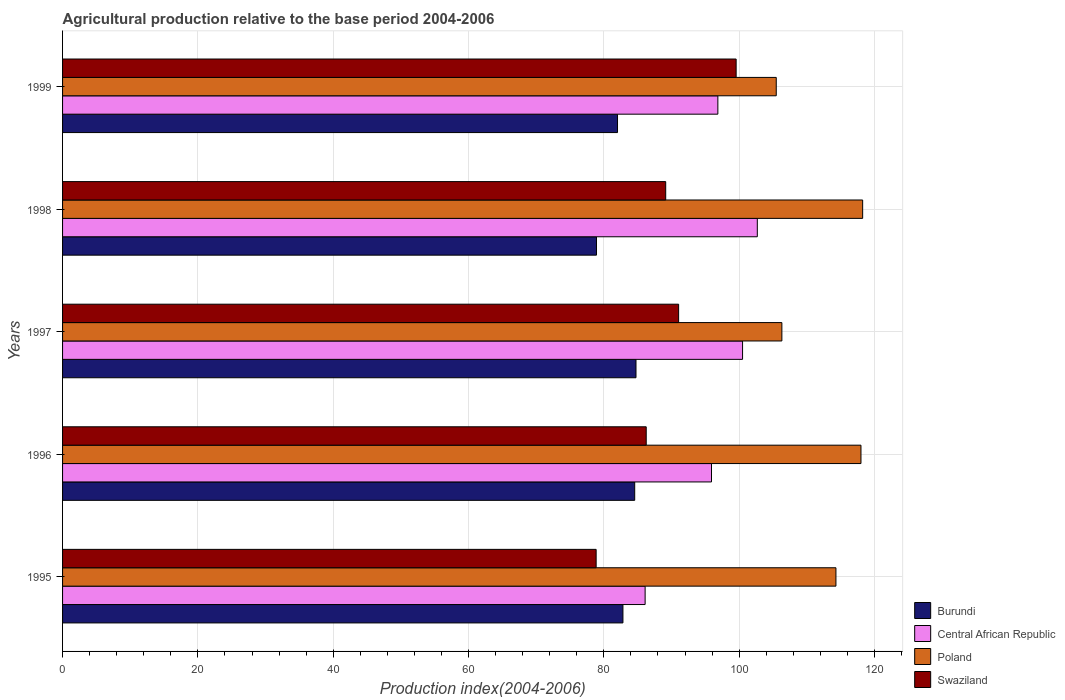How many different coloured bars are there?
Offer a terse response. 4. Are the number of bars per tick equal to the number of legend labels?
Keep it short and to the point. Yes. Are the number of bars on each tick of the Y-axis equal?
Provide a succinct answer. Yes. How many bars are there on the 5th tick from the top?
Make the answer very short. 4. What is the label of the 1st group of bars from the top?
Your response must be concise. 1999. In how many cases, is the number of bars for a given year not equal to the number of legend labels?
Your response must be concise. 0. What is the agricultural production index in Burundi in 1999?
Provide a succinct answer. 82.02. Across all years, what is the maximum agricultural production index in Burundi?
Keep it short and to the point. 84.75. Across all years, what is the minimum agricultural production index in Swaziland?
Provide a short and direct response. 78.86. In which year was the agricultural production index in Central African Republic minimum?
Keep it short and to the point. 1995. What is the total agricultural production index in Central African Republic in the graph?
Your response must be concise. 482.04. What is the difference between the agricultural production index in Swaziland in 1995 and that in 1997?
Your answer should be very brief. -12.19. What is the difference between the agricultural production index in Poland in 1996 and the agricultural production index in Swaziland in 1995?
Offer a terse response. 39.14. What is the average agricultural production index in Swaziland per year?
Keep it short and to the point. 88.97. In the year 1997, what is the difference between the agricultural production index in Burundi and agricultural production index in Poland?
Your response must be concise. -21.56. What is the ratio of the agricultural production index in Central African Republic in 1996 to that in 1999?
Keep it short and to the point. 0.99. Is the difference between the agricultural production index in Burundi in 1995 and 1997 greater than the difference between the agricultural production index in Poland in 1995 and 1997?
Offer a very short reply. No. What is the difference between the highest and the lowest agricultural production index in Poland?
Your response must be concise. 12.77. In how many years, is the agricultural production index in Swaziland greater than the average agricultural production index in Swaziland taken over all years?
Your answer should be compact. 3. What does the 2nd bar from the top in 1996 represents?
Make the answer very short. Poland. Is it the case that in every year, the sum of the agricultural production index in Central African Republic and agricultural production index in Swaziland is greater than the agricultural production index in Poland?
Your answer should be very brief. Yes. How many bars are there?
Offer a terse response. 20. Are all the bars in the graph horizontal?
Offer a terse response. Yes. Does the graph contain grids?
Provide a short and direct response. Yes. Where does the legend appear in the graph?
Offer a very short reply. Bottom right. What is the title of the graph?
Provide a short and direct response. Agricultural production relative to the base period 2004-2006. What is the label or title of the X-axis?
Keep it short and to the point. Production index(2004-2006). What is the Production index(2004-2006) in Burundi in 1995?
Your response must be concise. 82.82. What is the Production index(2004-2006) of Central African Republic in 1995?
Give a very brief answer. 86.1. What is the Production index(2004-2006) of Poland in 1995?
Provide a succinct answer. 114.3. What is the Production index(2004-2006) in Swaziland in 1995?
Give a very brief answer. 78.86. What is the Production index(2004-2006) in Burundi in 1996?
Your answer should be compact. 84.56. What is the Production index(2004-2006) in Central African Republic in 1996?
Your response must be concise. 95.91. What is the Production index(2004-2006) of Poland in 1996?
Keep it short and to the point. 118. What is the Production index(2004-2006) in Swaziland in 1996?
Keep it short and to the point. 86.26. What is the Production index(2004-2006) of Burundi in 1997?
Provide a succinct answer. 84.75. What is the Production index(2004-2006) in Central African Republic in 1997?
Offer a very short reply. 100.5. What is the Production index(2004-2006) in Poland in 1997?
Keep it short and to the point. 106.31. What is the Production index(2004-2006) of Swaziland in 1997?
Your answer should be compact. 91.05. What is the Production index(2004-2006) of Burundi in 1998?
Offer a very short reply. 78.91. What is the Production index(2004-2006) in Central African Republic in 1998?
Provide a succinct answer. 102.68. What is the Production index(2004-2006) in Poland in 1998?
Give a very brief answer. 118.25. What is the Production index(2004-2006) of Swaziland in 1998?
Keep it short and to the point. 89.14. What is the Production index(2004-2006) of Burundi in 1999?
Offer a terse response. 82.02. What is the Production index(2004-2006) in Central African Republic in 1999?
Provide a succinct answer. 96.85. What is the Production index(2004-2006) in Poland in 1999?
Provide a short and direct response. 105.48. What is the Production index(2004-2006) in Swaziland in 1999?
Offer a terse response. 99.55. Across all years, what is the maximum Production index(2004-2006) in Burundi?
Provide a short and direct response. 84.75. Across all years, what is the maximum Production index(2004-2006) of Central African Republic?
Keep it short and to the point. 102.68. Across all years, what is the maximum Production index(2004-2006) in Poland?
Your response must be concise. 118.25. Across all years, what is the maximum Production index(2004-2006) of Swaziland?
Offer a very short reply. 99.55. Across all years, what is the minimum Production index(2004-2006) in Burundi?
Provide a short and direct response. 78.91. Across all years, what is the minimum Production index(2004-2006) of Central African Republic?
Make the answer very short. 86.1. Across all years, what is the minimum Production index(2004-2006) in Poland?
Give a very brief answer. 105.48. Across all years, what is the minimum Production index(2004-2006) of Swaziland?
Make the answer very short. 78.86. What is the total Production index(2004-2006) in Burundi in the graph?
Your response must be concise. 413.06. What is the total Production index(2004-2006) in Central African Republic in the graph?
Provide a succinct answer. 482.04. What is the total Production index(2004-2006) of Poland in the graph?
Your answer should be very brief. 562.34. What is the total Production index(2004-2006) of Swaziland in the graph?
Make the answer very short. 444.86. What is the difference between the Production index(2004-2006) of Burundi in 1995 and that in 1996?
Make the answer very short. -1.74. What is the difference between the Production index(2004-2006) of Central African Republic in 1995 and that in 1996?
Make the answer very short. -9.81. What is the difference between the Production index(2004-2006) in Burundi in 1995 and that in 1997?
Provide a short and direct response. -1.93. What is the difference between the Production index(2004-2006) of Central African Republic in 1995 and that in 1997?
Your answer should be compact. -14.4. What is the difference between the Production index(2004-2006) of Poland in 1995 and that in 1997?
Your answer should be compact. 7.99. What is the difference between the Production index(2004-2006) in Swaziland in 1995 and that in 1997?
Ensure brevity in your answer.  -12.19. What is the difference between the Production index(2004-2006) in Burundi in 1995 and that in 1998?
Your answer should be very brief. 3.91. What is the difference between the Production index(2004-2006) in Central African Republic in 1995 and that in 1998?
Offer a terse response. -16.58. What is the difference between the Production index(2004-2006) of Poland in 1995 and that in 1998?
Ensure brevity in your answer.  -3.95. What is the difference between the Production index(2004-2006) of Swaziland in 1995 and that in 1998?
Offer a terse response. -10.28. What is the difference between the Production index(2004-2006) in Burundi in 1995 and that in 1999?
Your answer should be very brief. 0.8. What is the difference between the Production index(2004-2006) of Central African Republic in 1995 and that in 1999?
Your response must be concise. -10.75. What is the difference between the Production index(2004-2006) of Poland in 1995 and that in 1999?
Make the answer very short. 8.82. What is the difference between the Production index(2004-2006) in Swaziland in 1995 and that in 1999?
Offer a terse response. -20.69. What is the difference between the Production index(2004-2006) of Burundi in 1996 and that in 1997?
Ensure brevity in your answer.  -0.19. What is the difference between the Production index(2004-2006) of Central African Republic in 1996 and that in 1997?
Your response must be concise. -4.59. What is the difference between the Production index(2004-2006) of Poland in 1996 and that in 1997?
Offer a very short reply. 11.69. What is the difference between the Production index(2004-2006) in Swaziland in 1996 and that in 1997?
Your answer should be very brief. -4.79. What is the difference between the Production index(2004-2006) of Burundi in 1996 and that in 1998?
Offer a very short reply. 5.65. What is the difference between the Production index(2004-2006) in Central African Republic in 1996 and that in 1998?
Offer a very short reply. -6.77. What is the difference between the Production index(2004-2006) of Poland in 1996 and that in 1998?
Your response must be concise. -0.25. What is the difference between the Production index(2004-2006) in Swaziland in 1996 and that in 1998?
Give a very brief answer. -2.88. What is the difference between the Production index(2004-2006) of Burundi in 1996 and that in 1999?
Your response must be concise. 2.54. What is the difference between the Production index(2004-2006) in Central African Republic in 1996 and that in 1999?
Keep it short and to the point. -0.94. What is the difference between the Production index(2004-2006) in Poland in 1996 and that in 1999?
Keep it short and to the point. 12.52. What is the difference between the Production index(2004-2006) of Swaziland in 1996 and that in 1999?
Make the answer very short. -13.29. What is the difference between the Production index(2004-2006) of Burundi in 1997 and that in 1998?
Your response must be concise. 5.84. What is the difference between the Production index(2004-2006) in Central African Republic in 1997 and that in 1998?
Provide a succinct answer. -2.18. What is the difference between the Production index(2004-2006) in Poland in 1997 and that in 1998?
Make the answer very short. -11.94. What is the difference between the Production index(2004-2006) of Swaziland in 1997 and that in 1998?
Your answer should be compact. 1.91. What is the difference between the Production index(2004-2006) of Burundi in 1997 and that in 1999?
Offer a terse response. 2.73. What is the difference between the Production index(2004-2006) of Central African Republic in 1997 and that in 1999?
Your answer should be very brief. 3.65. What is the difference between the Production index(2004-2006) in Poland in 1997 and that in 1999?
Keep it short and to the point. 0.83. What is the difference between the Production index(2004-2006) of Swaziland in 1997 and that in 1999?
Provide a succinct answer. -8.5. What is the difference between the Production index(2004-2006) of Burundi in 1998 and that in 1999?
Offer a very short reply. -3.11. What is the difference between the Production index(2004-2006) in Central African Republic in 1998 and that in 1999?
Offer a very short reply. 5.83. What is the difference between the Production index(2004-2006) in Poland in 1998 and that in 1999?
Ensure brevity in your answer.  12.77. What is the difference between the Production index(2004-2006) in Swaziland in 1998 and that in 1999?
Offer a terse response. -10.41. What is the difference between the Production index(2004-2006) in Burundi in 1995 and the Production index(2004-2006) in Central African Republic in 1996?
Offer a very short reply. -13.09. What is the difference between the Production index(2004-2006) of Burundi in 1995 and the Production index(2004-2006) of Poland in 1996?
Your answer should be very brief. -35.18. What is the difference between the Production index(2004-2006) in Burundi in 1995 and the Production index(2004-2006) in Swaziland in 1996?
Make the answer very short. -3.44. What is the difference between the Production index(2004-2006) of Central African Republic in 1995 and the Production index(2004-2006) of Poland in 1996?
Provide a short and direct response. -31.9. What is the difference between the Production index(2004-2006) in Central African Republic in 1995 and the Production index(2004-2006) in Swaziland in 1996?
Offer a terse response. -0.16. What is the difference between the Production index(2004-2006) of Poland in 1995 and the Production index(2004-2006) of Swaziland in 1996?
Offer a very short reply. 28.04. What is the difference between the Production index(2004-2006) of Burundi in 1995 and the Production index(2004-2006) of Central African Republic in 1997?
Provide a short and direct response. -17.68. What is the difference between the Production index(2004-2006) in Burundi in 1995 and the Production index(2004-2006) in Poland in 1997?
Provide a short and direct response. -23.49. What is the difference between the Production index(2004-2006) in Burundi in 1995 and the Production index(2004-2006) in Swaziland in 1997?
Give a very brief answer. -8.23. What is the difference between the Production index(2004-2006) in Central African Republic in 1995 and the Production index(2004-2006) in Poland in 1997?
Your answer should be very brief. -20.21. What is the difference between the Production index(2004-2006) of Central African Republic in 1995 and the Production index(2004-2006) of Swaziland in 1997?
Provide a succinct answer. -4.95. What is the difference between the Production index(2004-2006) in Poland in 1995 and the Production index(2004-2006) in Swaziland in 1997?
Your answer should be compact. 23.25. What is the difference between the Production index(2004-2006) in Burundi in 1995 and the Production index(2004-2006) in Central African Republic in 1998?
Your response must be concise. -19.86. What is the difference between the Production index(2004-2006) in Burundi in 1995 and the Production index(2004-2006) in Poland in 1998?
Your answer should be compact. -35.43. What is the difference between the Production index(2004-2006) in Burundi in 1995 and the Production index(2004-2006) in Swaziland in 1998?
Provide a short and direct response. -6.32. What is the difference between the Production index(2004-2006) of Central African Republic in 1995 and the Production index(2004-2006) of Poland in 1998?
Your answer should be very brief. -32.15. What is the difference between the Production index(2004-2006) of Central African Republic in 1995 and the Production index(2004-2006) of Swaziland in 1998?
Your response must be concise. -3.04. What is the difference between the Production index(2004-2006) of Poland in 1995 and the Production index(2004-2006) of Swaziland in 1998?
Keep it short and to the point. 25.16. What is the difference between the Production index(2004-2006) in Burundi in 1995 and the Production index(2004-2006) in Central African Republic in 1999?
Provide a short and direct response. -14.03. What is the difference between the Production index(2004-2006) in Burundi in 1995 and the Production index(2004-2006) in Poland in 1999?
Your response must be concise. -22.66. What is the difference between the Production index(2004-2006) of Burundi in 1995 and the Production index(2004-2006) of Swaziland in 1999?
Make the answer very short. -16.73. What is the difference between the Production index(2004-2006) of Central African Republic in 1995 and the Production index(2004-2006) of Poland in 1999?
Your response must be concise. -19.38. What is the difference between the Production index(2004-2006) in Central African Republic in 1995 and the Production index(2004-2006) in Swaziland in 1999?
Offer a terse response. -13.45. What is the difference between the Production index(2004-2006) of Poland in 1995 and the Production index(2004-2006) of Swaziland in 1999?
Give a very brief answer. 14.75. What is the difference between the Production index(2004-2006) of Burundi in 1996 and the Production index(2004-2006) of Central African Republic in 1997?
Your response must be concise. -15.94. What is the difference between the Production index(2004-2006) in Burundi in 1996 and the Production index(2004-2006) in Poland in 1997?
Provide a short and direct response. -21.75. What is the difference between the Production index(2004-2006) of Burundi in 1996 and the Production index(2004-2006) of Swaziland in 1997?
Ensure brevity in your answer.  -6.49. What is the difference between the Production index(2004-2006) in Central African Republic in 1996 and the Production index(2004-2006) in Poland in 1997?
Give a very brief answer. -10.4. What is the difference between the Production index(2004-2006) of Central African Republic in 1996 and the Production index(2004-2006) of Swaziland in 1997?
Your response must be concise. 4.86. What is the difference between the Production index(2004-2006) of Poland in 1996 and the Production index(2004-2006) of Swaziland in 1997?
Give a very brief answer. 26.95. What is the difference between the Production index(2004-2006) of Burundi in 1996 and the Production index(2004-2006) of Central African Republic in 1998?
Provide a short and direct response. -18.12. What is the difference between the Production index(2004-2006) in Burundi in 1996 and the Production index(2004-2006) in Poland in 1998?
Keep it short and to the point. -33.69. What is the difference between the Production index(2004-2006) in Burundi in 1996 and the Production index(2004-2006) in Swaziland in 1998?
Offer a terse response. -4.58. What is the difference between the Production index(2004-2006) in Central African Republic in 1996 and the Production index(2004-2006) in Poland in 1998?
Your answer should be compact. -22.34. What is the difference between the Production index(2004-2006) of Central African Republic in 1996 and the Production index(2004-2006) of Swaziland in 1998?
Offer a very short reply. 6.77. What is the difference between the Production index(2004-2006) in Poland in 1996 and the Production index(2004-2006) in Swaziland in 1998?
Make the answer very short. 28.86. What is the difference between the Production index(2004-2006) of Burundi in 1996 and the Production index(2004-2006) of Central African Republic in 1999?
Your answer should be compact. -12.29. What is the difference between the Production index(2004-2006) of Burundi in 1996 and the Production index(2004-2006) of Poland in 1999?
Offer a terse response. -20.92. What is the difference between the Production index(2004-2006) in Burundi in 1996 and the Production index(2004-2006) in Swaziland in 1999?
Give a very brief answer. -14.99. What is the difference between the Production index(2004-2006) of Central African Republic in 1996 and the Production index(2004-2006) of Poland in 1999?
Keep it short and to the point. -9.57. What is the difference between the Production index(2004-2006) in Central African Republic in 1996 and the Production index(2004-2006) in Swaziland in 1999?
Your answer should be very brief. -3.64. What is the difference between the Production index(2004-2006) of Poland in 1996 and the Production index(2004-2006) of Swaziland in 1999?
Ensure brevity in your answer.  18.45. What is the difference between the Production index(2004-2006) of Burundi in 1997 and the Production index(2004-2006) of Central African Republic in 1998?
Provide a succinct answer. -17.93. What is the difference between the Production index(2004-2006) in Burundi in 1997 and the Production index(2004-2006) in Poland in 1998?
Offer a terse response. -33.5. What is the difference between the Production index(2004-2006) in Burundi in 1997 and the Production index(2004-2006) in Swaziland in 1998?
Ensure brevity in your answer.  -4.39. What is the difference between the Production index(2004-2006) in Central African Republic in 1997 and the Production index(2004-2006) in Poland in 1998?
Keep it short and to the point. -17.75. What is the difference between the Production index(2004-2006) in Central African Republic in 1997 and the Production index(2004-2006) in Swaziland in 1998?
Your answer should be compact. 11.36. What is the difference between the Production index(2004-2006) in Poland in 1997 and the Production index(2004-2006) in Swaziland in 1998?
Your response must be concise. 17.17. What is the difference between the Production index(2004-2006) in Burundi in 1997 and the Production index(2004-2006) in Central African Republic in 1999?
Ensure brevity in your answer.  -12.1. What is the difference between the Production index(2004-2006) in Burundi in 1997 and the Production index(2004-2006) in Poland in 1999?
Your answer should be very brief. -20.73. What is the difference between the Production index(2004-2006) in Burundi in 1997 and the Production index(2004-2006) in Swaziland in 1999?
Offer a terse response. -14.8. What is the difference between the Production index(2004-2006) in Central African Republic in 1997 and the Production index(2004-2006) in Poland in 1999?
Give a very brief answer. -4.98. What is the difference between the Production index(2004-2006) of Poland in 1997 and the Production index(2004-2006) of Swaziland in 1999?
Your answer should be compact. 6.76. What is the difference between the Production index(2004-2006) of Burundi in 1998 and the Production index(2004-2006) of Central African Republic in 1999?
Your answer should be compact. -17.94. What is the difference between the Production index(2004-2006) of Burundi in 1998 and the Production index(2004-2006) of Poland in 1999?
Offer a terse response. -26.57. What is the difference between the Production index(2004-2006) of Burundi in 1998 and the Production index(2004-2006) of Swaziland in 1999?
Keep it short and to the point. -20.64. What is the difference between the Production index(2004-2006) in Central African Republic in 1998 and the Production index(2004-2006) in Swaziland in 1999?
Offer a very short reply. 3.13. What is the average Production index(2004-2006) in Burundi per year?
Your answer should be very brief. 82.61. What is the average Production index(2004-2006) in Central African Republic per year?
Give a very brief answer. 96.41. What is the average Production index(2004-2006) in Poland per year?
Provide a short and direct response. 112.47. What is the average Production index(2004-2006) of Swaziland per year?
Your answer should be compact. 88.97. In the year 1995, what is the difference between the Production index(2004-2006) of Burundi and Production index(2004-2006) of Central African Republic?
Provide a short and direct response. -3.28. In the year 1995, what is the difference between the Production index(2004-2006) in Burundi and Production index(2004-2006) in Poland?
Provide a short and direct response. -31.48. In the year 1995, what is the difference between the Production index(2004-2006) in Burundi and Production index(2004-2006) in Swaziland?
Make the answer very short. 3.96. In the year 1995, what is the difference between the Production index(2004-2006) of Central African Republic and Production index(2004-2006) of Poland?
Offer a terse response. -28.2. In the year 1995, what is the difference between the Production index(2004-2006) in Central African Republic and Production index(2004-2006) in Swaziland?
Provide a short and direct response. 7.24. In the year 1995, what is the difference between the Production index(2004-2006) of Poland and Production index(2004-2006) of Swaziland?
Your answer should be compact. 35.44. In the year 1996, what is the difference between the Production index(2004-2006) of Burundi and Production index(2004-2006) of Central African Republic?
Provide a short and direct response. -11.35. In the year 1996, what is the difference between the Production index(2004-2006) in Burundi and Production index(2004-2006) in Poland?
Provide a short and direct response. -33.44. In the year 1996, what is the difference between the Production index(2004-2006) of Central African Republic and Production index(2004-2006) of Poland?
Your answer should be very brief. -22.09. In the year 1996, what is the difference between the Production index(2004-2006) of Central African Republic and Production index(2004-2006) of Swaziland?
Your answer should be very brief. 9.65. In the year 1996, what is the difference between the Production index(2004-2006) in Poland and Production index(2004-2006) in Swaziland?
Make the answer very short. 31.74. In the year 1997, what is the difference between the Production index(2004-2006) in Burundi and Production index(2004-2006) in Central African Republic?
Your response must be concise. -15.75. In the year 1997, what is the difference between the Production index(2004-2006) in Burundi and Production index(2004-2006) in Poland?
Your response must be concise. -21.56. In the year 1997, what is the difference between the Production index(2004-2006) in Central African Republic and Production index(2004-2006) in Poland?
Make the answer very short. -5.81. In the year 1997, what is the difference between the Production index(2004-2006) in Central African Republic and Production index(2004-2006) in Swaziland?
Give a very brief answer. 9.45. In the year 1997, what is the difference between the Production index(2004-2006) in Poland and Production index(2004-2006) in Swaziland?
Your response must be concise. 15.26. In the year 1998, what is the difference between the Production index(2004-2006) of Burundi and Production index(2004-2006) of Central African Republic?
Your answer should be compact. -23.77. In the year 1998, what is the difference between the Production index(2004-2006) in Burundi and Production index(2004-2006) in Poland?
Keep it short and to the point. -39.34. In the year 1998, what is the difference between the Production index(2004-2006) of Burundi and Production index(2004-2006) of Swaziland?
Make the answer very short. -10.23. In the year 1998, what is the difference between the Production index(2004-2006) in Central African Republic and Production index(2004-2006) in Poland?
Provide a succinct answer. -15.57. In the year 1998, what is the difference between the Production index(2004-2006) of Central African Republic and Production index(2004-2006) of Swaziland?
Your answer should be compact. 13.54. In the year 1998, what is the difference between the Production index(2004-2006) of Poland and Production index(2004-2006) of Swaziland?
Offer a terse response. 29.11. In the year 1999, what is the difference between the Production index(2004-2006) of Burundi and Production index(2004-2006) of Central African Republic?
Offer a very short reply. -14.83. In the year 1999, what is the difference between the Production index(2004-2006) of Burundi and Production index(2004-2006) of Poland?
Offer a very short reply. -23.46. In the year 1999, what is the difference between the Production index(2004-2006) of Burundi and Production index(2004-2006) of Swaziland?
Provide a short and direct response. -17.53. In the year 1999, what is the difference between the Production index(2004-2006) of Central African Republic and Production index(2004-2006) of Poland?
Your answer should be very brief. -8.63. In the year 1999, what is the difference between the Production index(2004-2006) in Poland and Production index(2004-2006) in Swaziland?
Keep it short and to the point. 5.93. What is the ratio of the Production index(2004-2006) in Burundi in 1995 to that in 1996?
Your response must be concise. 0.98. What is the ratio of the Production index(2004-2006) of Central African Republic in 1995 to that in 1996?
Provide a short and direct response. 0.9. What is the ratio of the Production index(2004-2006) in Poland in 1995 to that in 1996?
Ensure brevity in your answer.  0.97. What is the ratio of the Production index(2004-2006) in Swaziland in 1995 to that in 1996?
Offer a very short reply. 0.91. What is the ratio of the Production index(2004-2006) in Burundi in 1995 to that in 1997?
Give a very brief answer. 0.98. What is the ratio of the Production index(2004-2006) of Central African Republic in 1995 to that in 1997?
Give a very brief answer. 0.86. What is the ratio of the Production index(2004-2006) of Poland in 1995 to that in 1997?
Provide a short and direct response. 1.08. What is the ratio of the Production index(2004-2006) in Swaziland in 1995 to that in 1997?
Provide a short and direct response. 0.87. What is the ratio of the Production index(2004-2006) of Burundi in 1995 to that in 1998?
Offer a very short reply. 1.05. What is the ratio of the Production index(2004-2006) in Central African Republic in 1995 to that in 1998?
Provide a short and direct response. 0.84. What is the ratio of the Production index(2004-2006) in Poland in 1995 to that in 1998?
Offer a terse response. 0.97. What is the ratio of the Production index(2004-2006) in Swaziland in 1995 to that in 1998?
Give a very brief answer. 0.88. What is the ratio of the Production index(2004-2006) of Burundi in 1995 to that in 1999?
Offer a terse response. 1.01. What is the ratio of the Production index(2004-2006) of Central African Republic in 1995 to that in 1999?
Your answer should be very brief. 0.89. What is the ratio of the Production index(2004-2006) in Poland in 1995 to that in 1999?
Keep it short and to the point. 1.08. What is the ratio of the Production index(2004-2006) of Swaziland in 1995 to that in 1999?
Offer a very short reply. 0.79. What is the ratio of the Production index(2004-2006) of Burundi in 1996 to that in 1997?
Provide a short and direct response. 1. What is the ratio of the Production index(2004-2006) of Central African Republic in 1996 to that in 1997?
Your answer should be compact. 0.95. What is the ratio of the Production index(2004-2006) in Poland in 1996 to that in 1997?
Offer a very short reply. 1.11. What is the ratio of the Production index(2004-2006) in Burundi in 1996 to that in 1998?
Provide a succinct answer. 1.07. What is the ratio of the Production index(2004-2006) of Central African Republic in 1996 to that in 1998?
Offer a very short reply. 0.93. What is the ratio of the Production index(2004-2006) in Burundi in 1996 to that in 1999?
Your answer should be very brief. 1.03. What is the ratio of the Production index(2004-2006) in Central African Republic in 1996 to that in 1999?
Provide a succinct answer. 0.99. What is the ratio of the Production index(2004-2006) of Poland in 1996 to that in 1999?
Keep it short and to the point. 1.12. What is the ratio of the Production index(2004-2006) of Swaziland in 1996 to that in 1999?
Your answer should be compact. 0.87. What is the ratio of the Production index(2004-2006) in Burundi in 1997 to that in 1998?
Keep it short and to the point. 1.07. What is the ratio of the Production index(2004-2006) in Central African Republic in 1997 to that in 1998?
Give a very brief answer. 0.98. What is the ratio of the Production index(2004-2006) in Poland in 1997 to that in 1998?
Provide a short and direct response. 0.9. What is the ratio of the Production index(2004-2006) in Swaziland in 1997 to that in 1998?
Provide a succinct answer. 1.02. What is the ratio of the Production index(2004-2006) in Central African Republic in 1997 to that in 1999?
Ensure brevity in your answer.  1.04. What is the ratio of the Production index(2004-2006) in Poland in 1997 to that in 1999?
Provide a short and direct response. 1.01. What is the ratio of the Production index(2004-2006) of Swaziland in 1997 to that in 1999?
Provide a succinct answer. 0.91. What is the ratio of the Production index(2004-2006) in Burundi in 1998 to that in 1999?
Make the answer very short. 0.96. What is the ratio of the Production index(2004-2006) of Central African Republic in 1998 to that in 1999?
Your answer should be compact. 1.06. What is the ratio of the Production index(2004-2006) of Poland in 1998 to that in 1999?
Keep it short and to the point. 1.12. What is the ratio of the Production index(2004-2006) in Swaziland in 1998 to that in 1999?
Your response must be concise. 0.9. What is the difference between the highest and the second highest Production index(2004-2006) in Burundi?
Make the answer very short. 0.19. What is the difference between the highest and the second highest Production index(2004-2006) of Central African Republic?
Provide a succinct answer. 2.18. What is the difference between the highest and the second highest Production index(2004-2006) in Swaziland?
Offer a terse response. 8.5. What is the difference between the highest and the lowest Production index(2004-2006) of Burundi?
Ensure brevity in your answer.  5.84. What is the difference between the highest and the lowest Production index(2004-2006) of Central African Republic?
Provide a succinct answer. 16.58. What is the difference between the highest and the lowest Production index(2004-2006) of Poland?
Offer a terse response. 12.77. What is the difference between the highest and the lowest Production index(2004-2006) of Swaziland?
Make the answer very short. 20.69. 